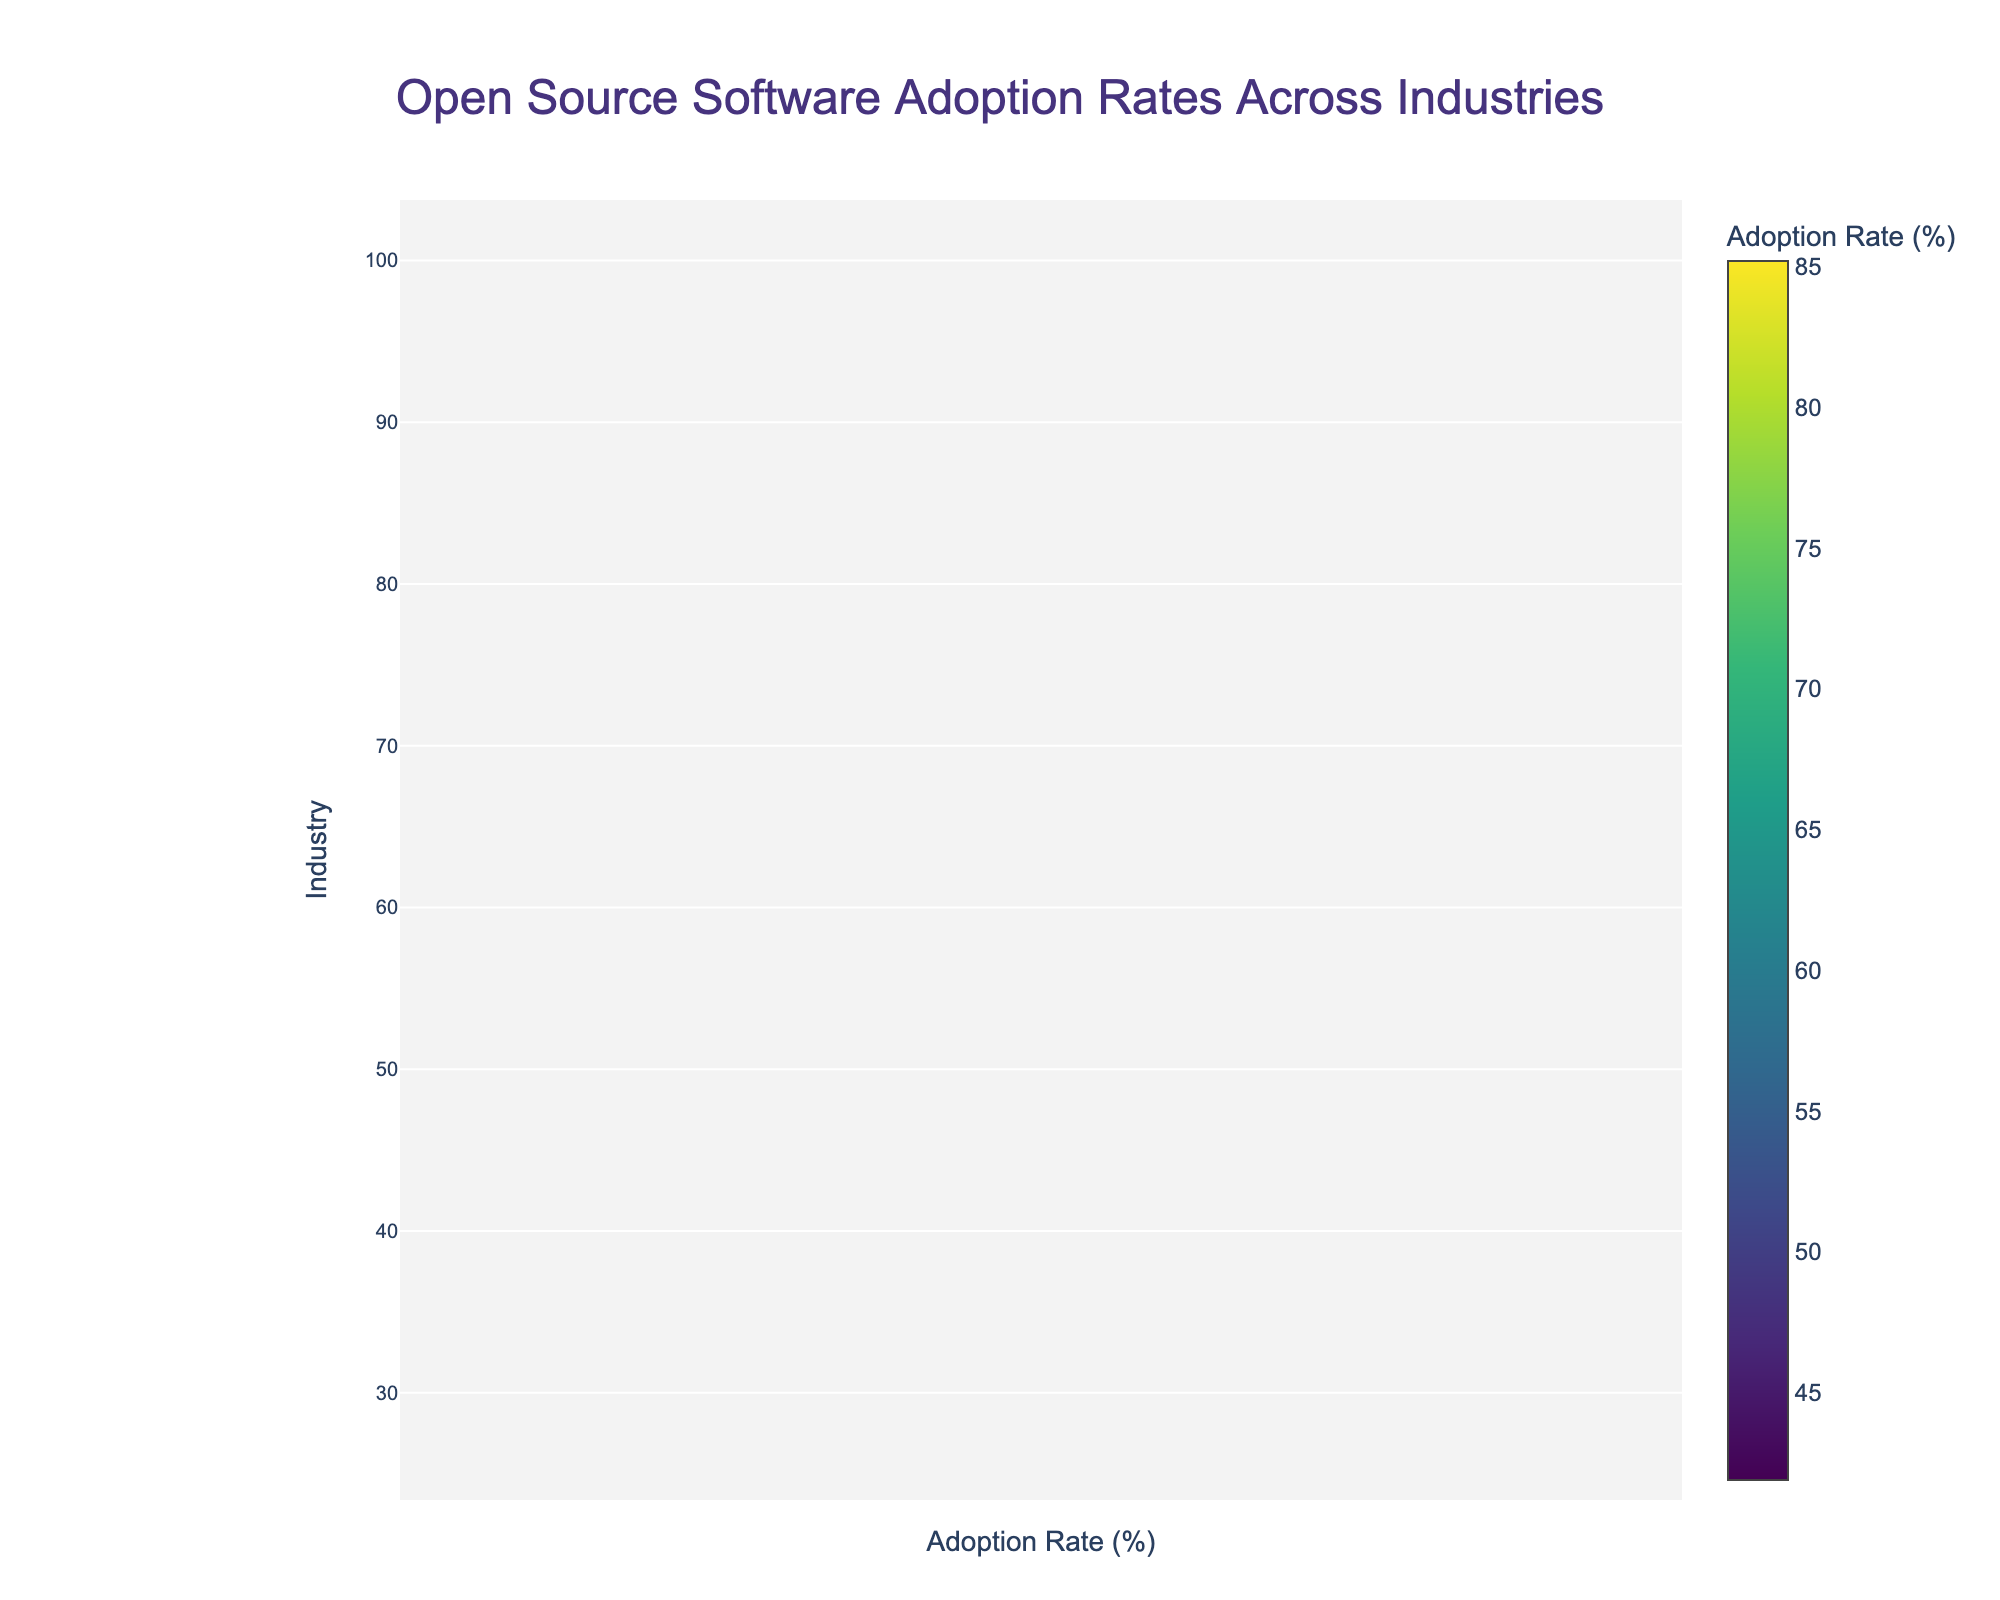What is the highest adoption rate shown in the figure? The highest data point on the violin plot corresponds to the sector with the highest adoption rate. Looking at the top-most point on the vertical axis representing adoption rate, we see the highest rate is noted.
Answer: 85.2% What industry has the lowest adoption rate of open source software? The scatter plot displays specific data points for each industry. The industry at the very bottom of the vertical axis has the lowest adoption rate.
Answer: Energy What is the title of the figure? The title of the figure is located at the top of the plot. It provides a concise summary of what the figure is about.
Answer: Open Source Software Adoption Rates Across Industries How many industries have an adoption rate above 60%? By counting the number of points above the 60% mark on the vertical axis in the scatter plot, we determine how many industries surpass this threshold.
Answer: 10 Which industry has a higher adoption rate, Healthcare or Retail? Locate the points corresponding to Healthcare and Retail on the scatter plot and compare their vertical positions. Retail's point is higher.
Answer: Retail What's the median adoption rate shown in this figure? The violin plot typically includes a line indicating the median of the data. This line is visible within the density distribution.
Answer: Around 59.7% (Retail) What is the range of adoption rates displayed on the x-axis? The x-axis label ranges provide the minimum and maximum values displayed on the horizontal axis for adoption rates.
Answer: 35% to 90% How does the adoption rate in Finance compare to Biotechnology? Locate the data points for Finance and Biotechnology on the scatter plot, and compare their vertical positions to determine which is higher.
Answer: Finance (Finance = 53.9%, Biotechnology = 48.6%) Which sectors have adoption rates close to the mean? The mean line in the violin plot shows the average value, and the sectors closest to this line in the scatter plot are the answer.
Answer: Retail and Manufacturing What is the color scheme used for the scatter plot points? The color of the scatter plot points is indicated in the figure's legend or color bar, and observing this provides the information.
Answer: Viridis colorscale 